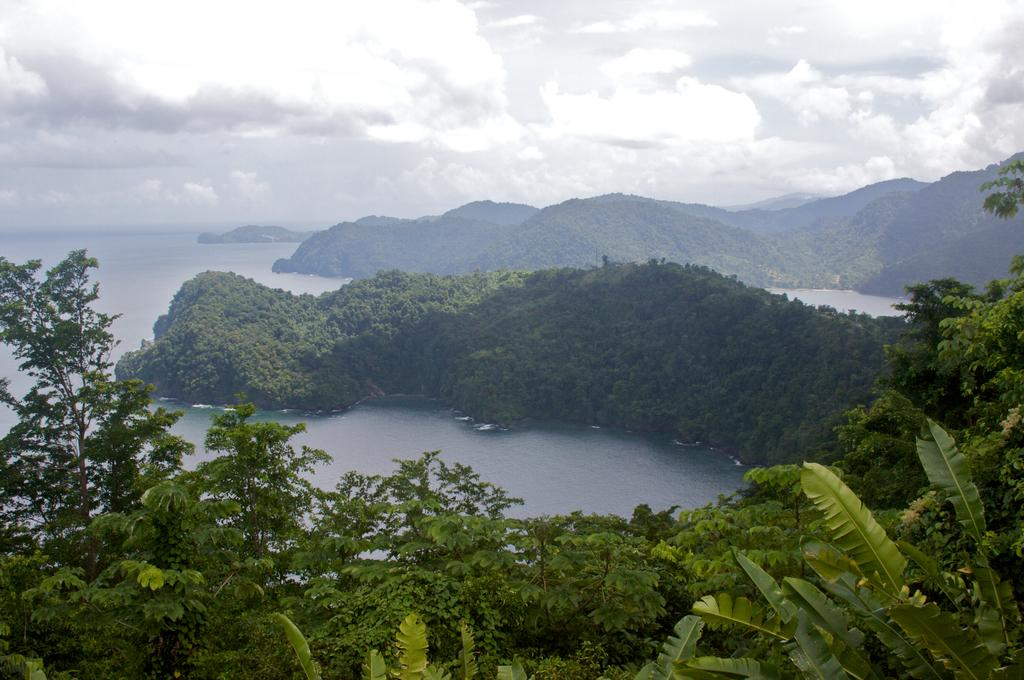What is the condition of the sky in the image? The sky in the image is cloudy. What type of vegetation can be seen in the image? There are trees visible in the image. What geographical feature is present in the image? There is a hill in the image. What natural element is visible in the image? There is water visible in the image. What is the weight of the secretary in the image? There is no secretary present in the image, so it is not possible to determine their weight. 